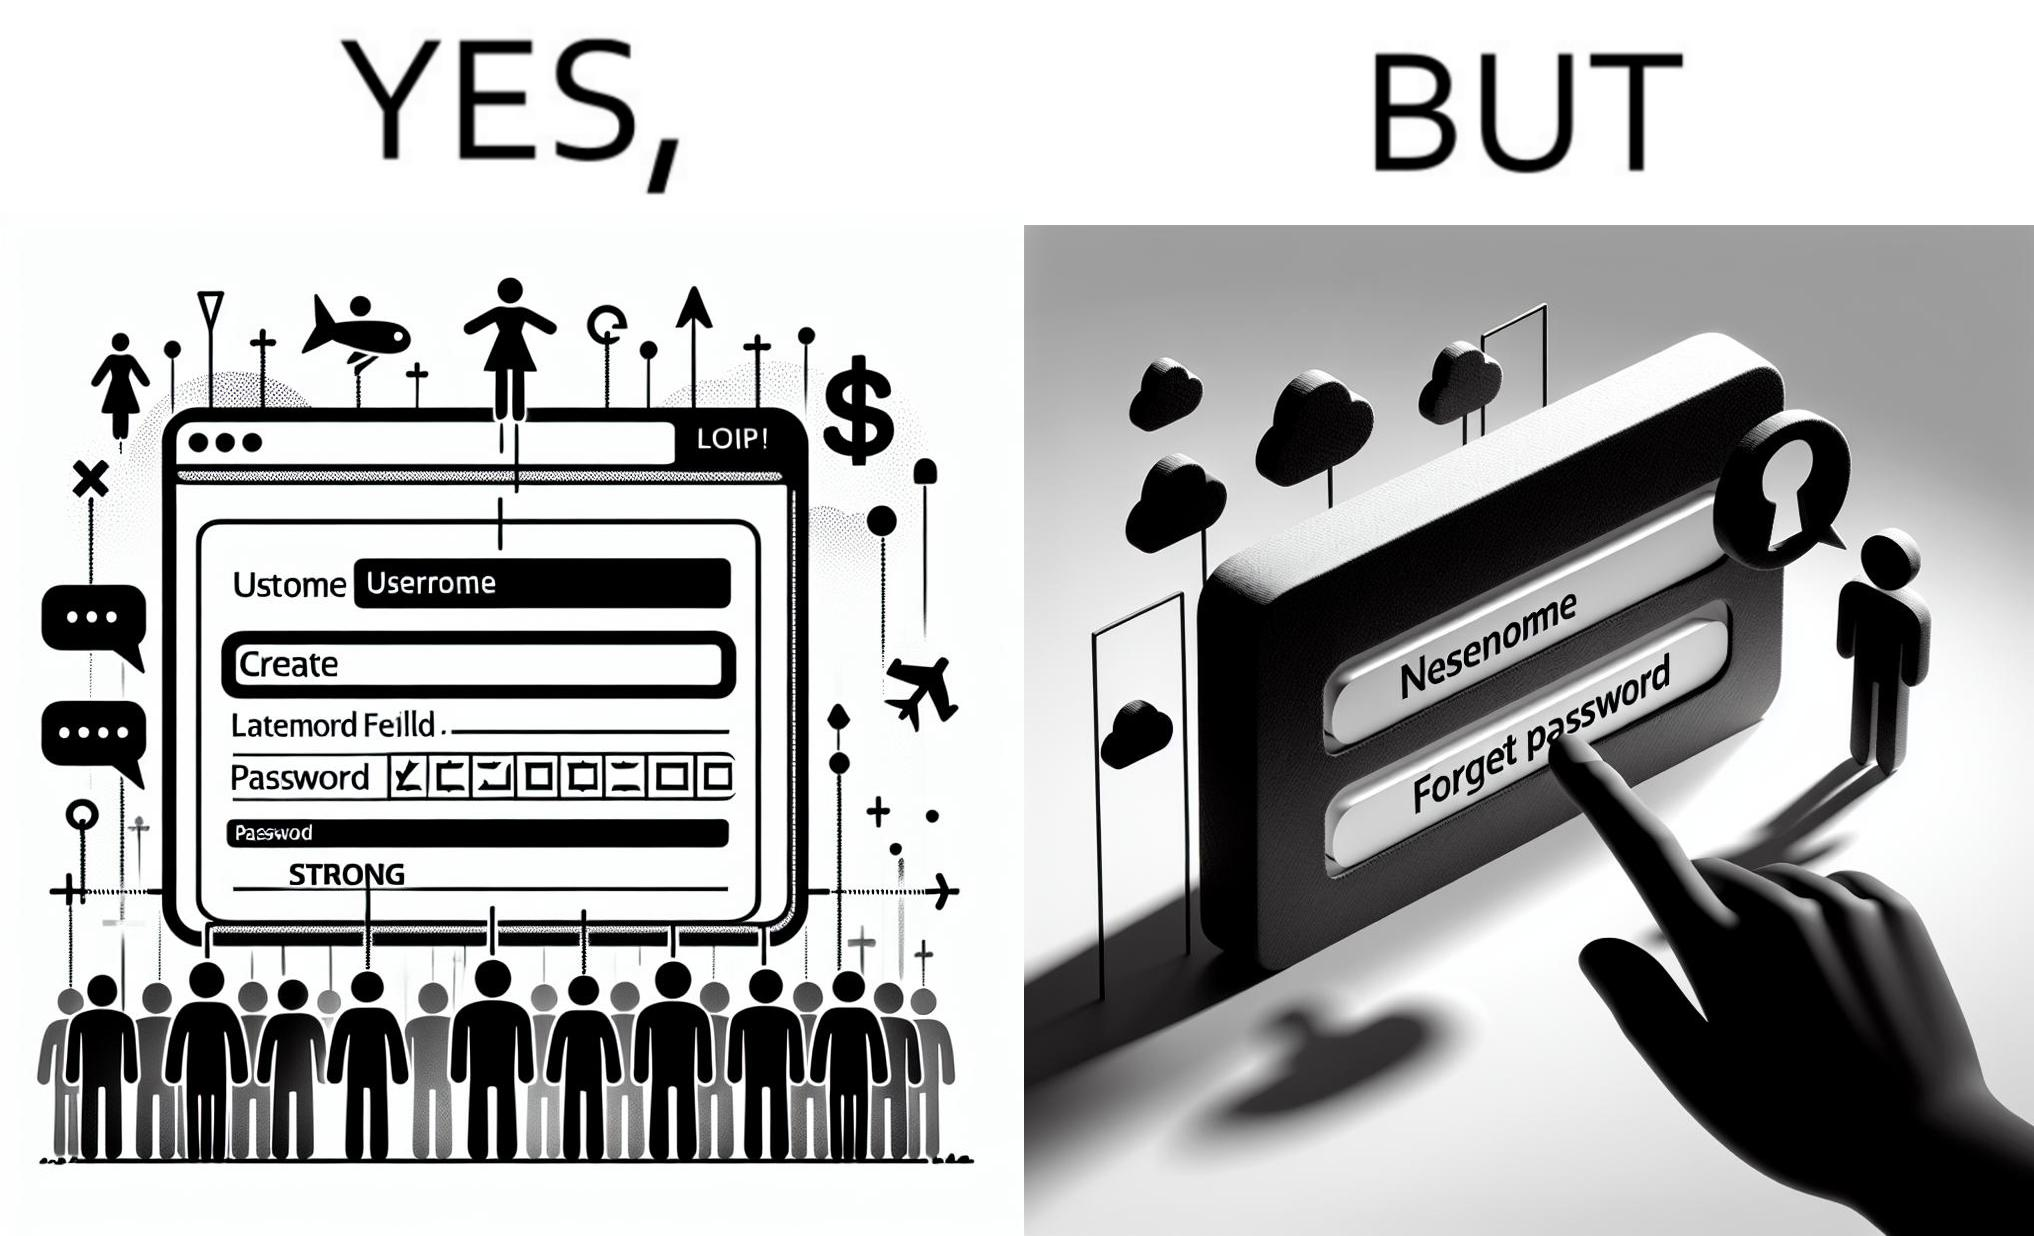Describe what you see in the left and right parts of this image. In the left part of the image: a screenshot of an account creation page of some site with login details filled in such as username and create password and password strength checker showing password as "strong" In the right part of the image: a screenshot of a login page of some site with username filled in and the user about to click on "Forget Password" link as the pointer is over the link 